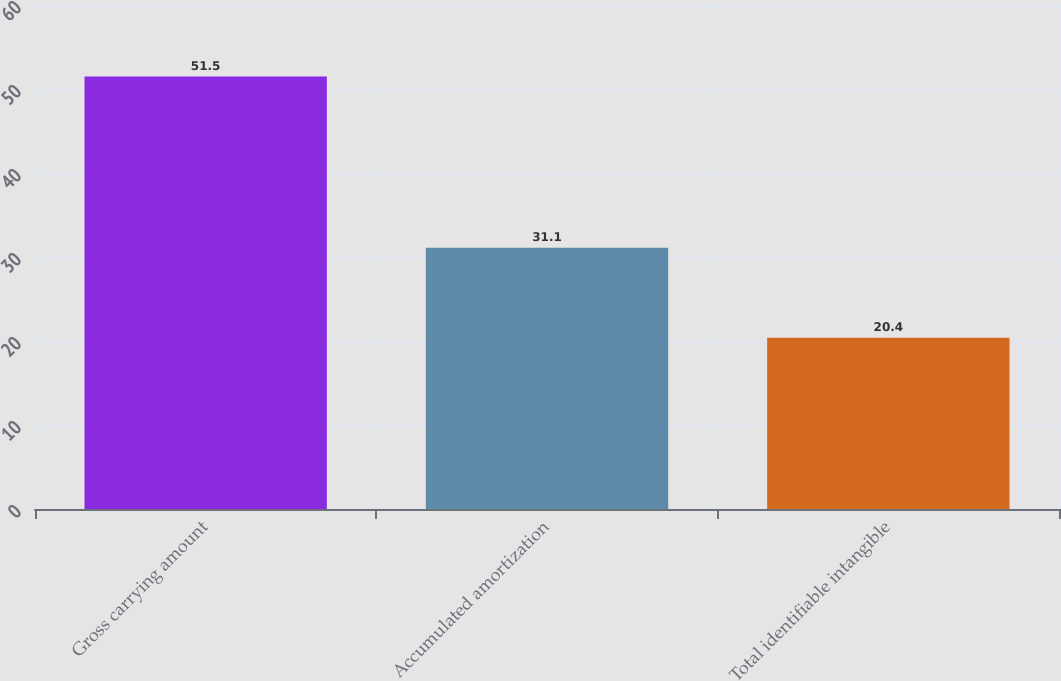Convert chart. <chart><loc_0><loc_0><loc_500><loc_500><bar_chart><fcel>Gross carrying amount<fcel>Accumulated amortization<fcel>Total identifiable intangible<nl><fcel>51.5<fcel>31.1<fcel>20.4<nl></chart> 